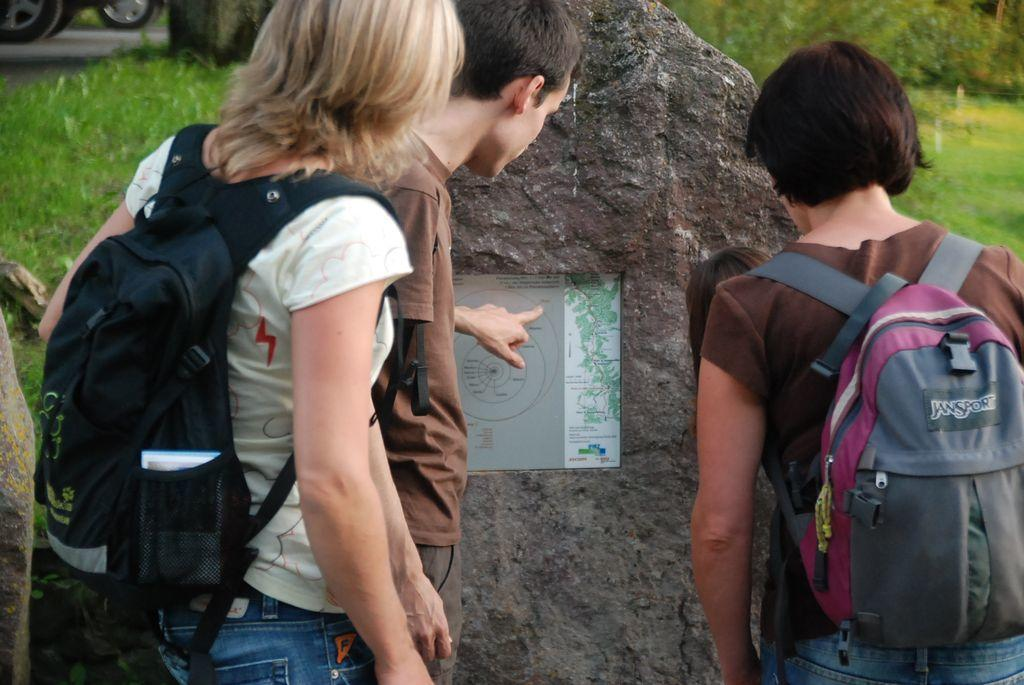<image>
Summarize the visual content of the image. a Jansport backpack on the back of a person 